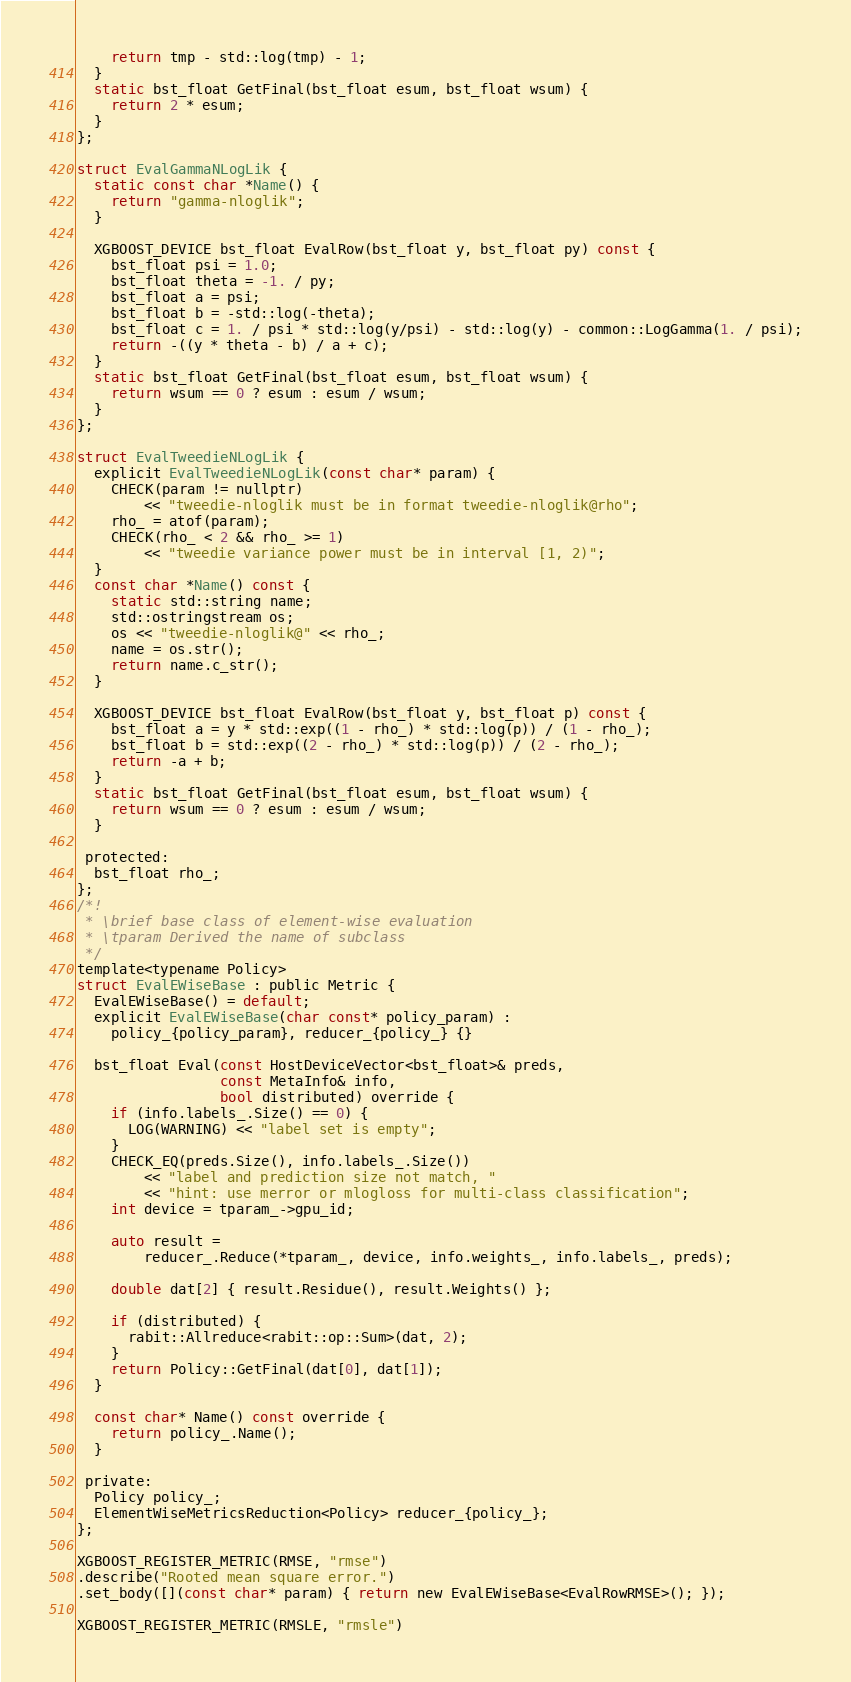Convert code to text. <code><loc_0><loc_0><loc_500><loc_500><_Cuda_>    return tmp - std::log(tmp) - 1;
  }
  static bst_float GetFinal(bst_float esum, bst_float wsum) {
    return 2 * esum;
  }
};

struct EvalGammaNLogLik {
  static const char *Name() {
    return "gamma-nloglik";
  }

  XGBOOST_DEVICE bst_float EvalRow(bst_float y, bst_float py) const {
    bst_float psi = 1.0;
    bst_float theta = -1. / py;
    bst_float a = psi;
    bst_float b = -std::log(-theta);
    bst_float c = 1. / psi * std::log(y/psi) - std::log(y) - common::LogGamma(1. / psi);
    return -((y * theta - b) / a + c);
  }
  static bst_float GetFinal(bst_float esum, bst_float wsum) {
    return wsum == 0 ? esum : esum / wsum;
  }
};

struct EvalTweedieNLogLik {
  explicit EvalTweedieNLogLik(const char* param) {
    CHECK(param != nullptr)
        << "tweedie-nloglik must be in format tweedie-nloglik@rho";
    rho_ = atof(param);
    CHECK(rho_ < 2 && rho_ >= 1)
        << "tweedie variance power must be in interval [1, 2)";
  }
  const char *Name() const {
    static std::string name;
    std::ostringstream os;
    os << "tweedie-nloglik@" << rho_;
    name = os.str();
    return name.c_str();
  }

  XGBOOST_DEVICE bst_float EvalRow(bst_float y, bst_float p) const {
    bst_float a = y * std::exp((1 - rho_) * std::log(p)) / (1 - rho_);
    bst_float b = std::exp((2 - rho_) * std::log(p)) / (2 - rho_);
    return -a + b;
  }
  static bst_float GetFinal(bst_float esum, bst_float wsum) {
    return wsum == 0 ? esum : esum / wsum;
  }

 protected:
  bst_float rho_;
};
/*!
 * \brief base class of element-wise evaluation
 * \tparam Derived the name of subclass
 */
template<typename Policy>
struct EvalEWiseBase : public Metric {
  EvalEWiseBase() = default;
  explicit EvalEWiseBase(char const* policy_param) :
    policy_{policy_param}, reducer_{policy_} {}

  bst_float Eval(const HostDeviceVector<bst_float>& preds,
                 const MetaInfo& info,
                 bool distributed) override {
    if (info.labels_.Size() == 0) {
      LOG(WARNING) << "label set is empty";
    }
    CHECK_EQ(preds.Size(), info.labels_.Size())
        << "label and prediction size not match, "
        << "hint: use merror or mlogloss for multi-class classification";
    int device = tparam_->gpu_id;

    auto result =
        reducer_.Reduce(*tparam_, device, info.weights_, info.labels_, preds);

    double dat[2] { result.Residue(), result.Weights() };

    if (distributed) {
      rabit::Allreduce<rabit::op::Sum>(dat, 2);
    }
    return Policy::GetFinal(dat[0], dat[1]);
  }

  const char* Name() const override {
    return policy_.Name();
  }

 private:
  Policy policy_;
  ElementWiseMetricsReduction<Policy> reducer_{policy_};
};

XGBOOST_REGISTER_METRIC(RMSE, "rmse")
.describe("Rooted mean square error.")
.set_body([](const char* param) { return new EvalEWiseBase<EvalRowRMSE>(); });

XGBOOST_REGISTER_METRIC(RMSLE, "rmsle")</code> 